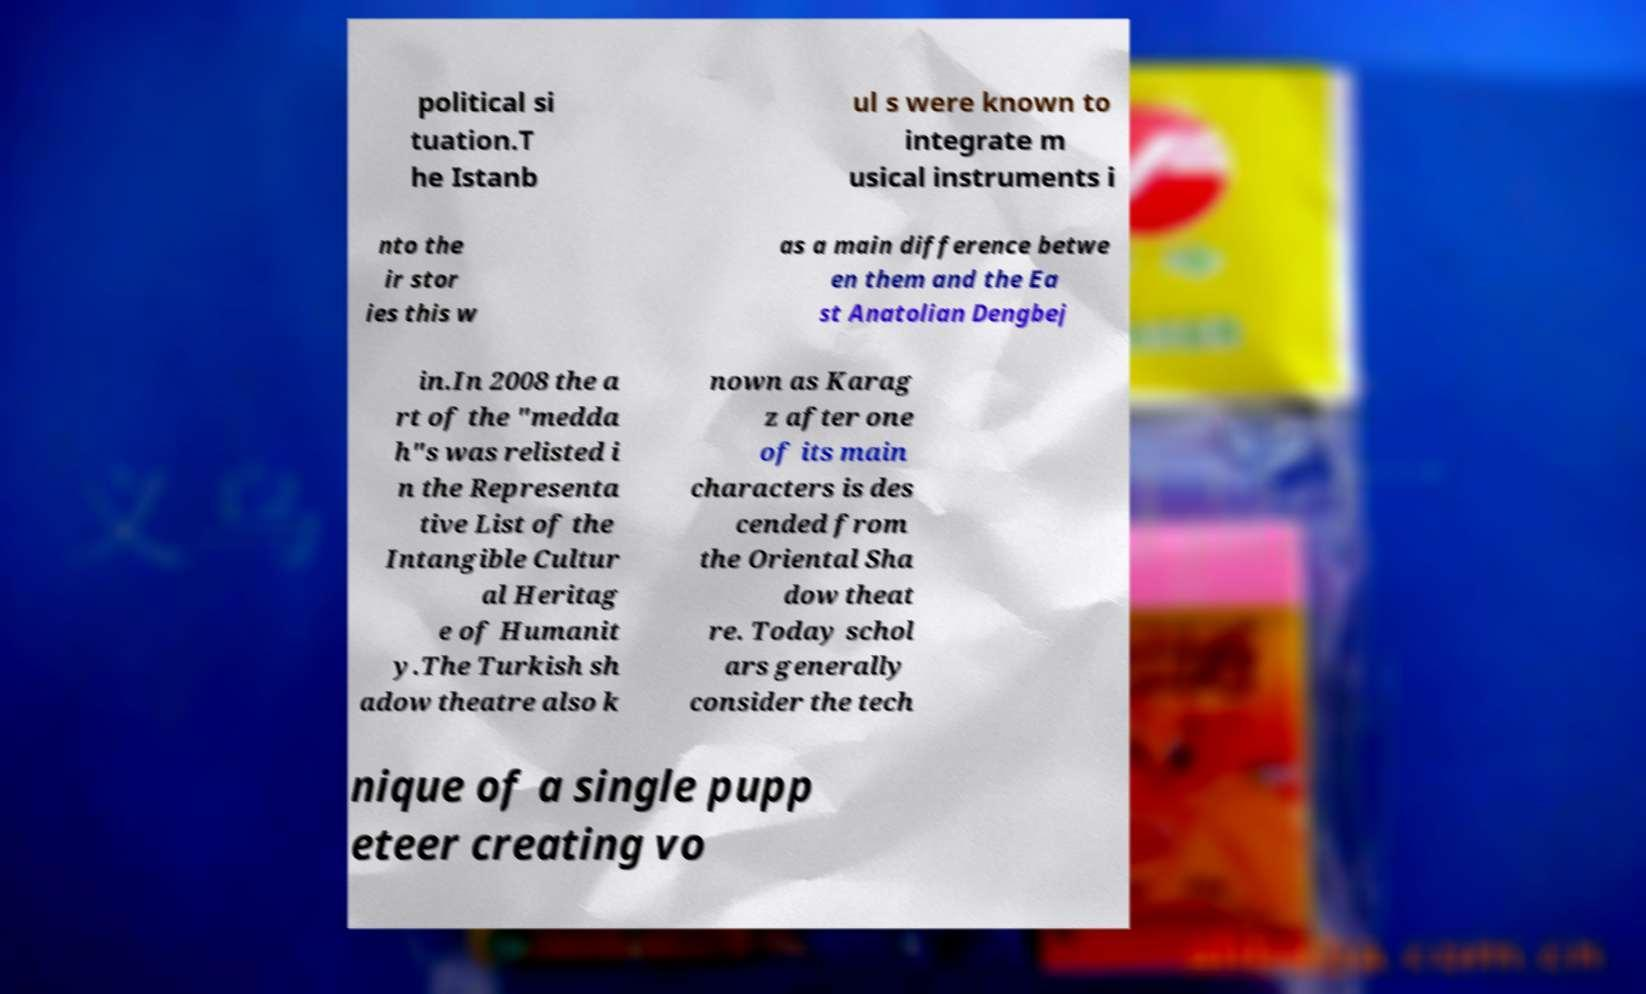Could you assist in decoding the text presented in this image and type it out clearly? political si tuation.T he Istanb ul s were known to integrate m usical instruments i nto the ir stor ies this w as a main difference betwe en them and the Ea st Anatolian Dengbej in.In 2008 the a rt of the "medda h"s was relisted i n the Representa tive List of the Intangible Cultur al Heritag e of Humanit y.The Turkish sh adow theatre also k nown as Karag z after one of its main characters is des cended from the Oriental Sha dow theat re. Today schol ars generally consider the tech nique of a single pupp eteer creating vo 